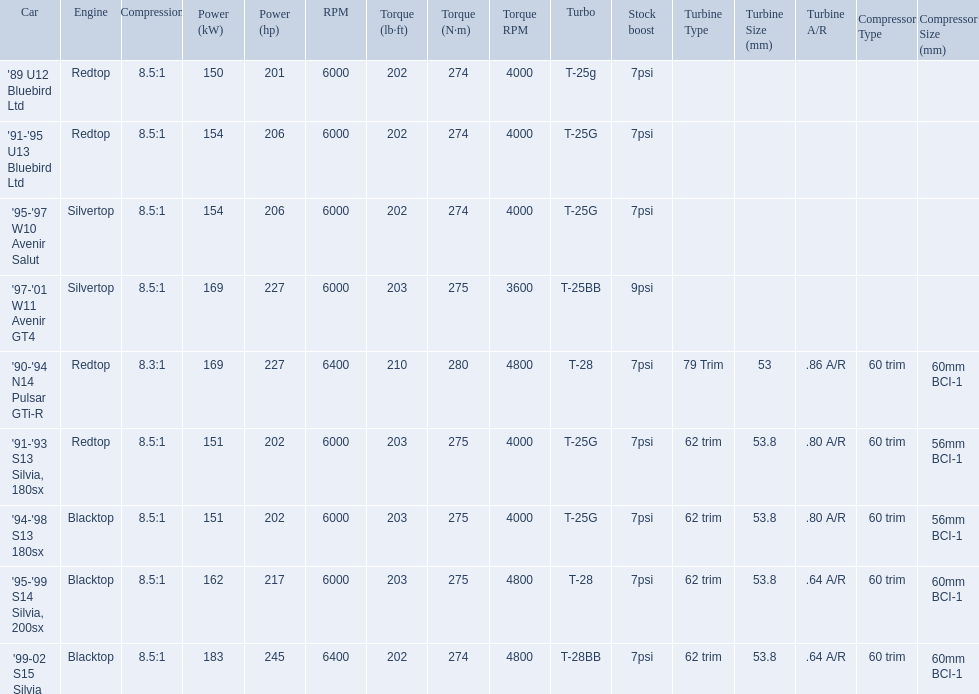What are the psi's? 7psi, 7psi, 7psi, 9psi, 7psi, 7psi, 7psi, 7psi, 7psi. What are the number(s) greater than 7? 9psi. Which car has that number? '97-'01 W11 Avenir GT4. 